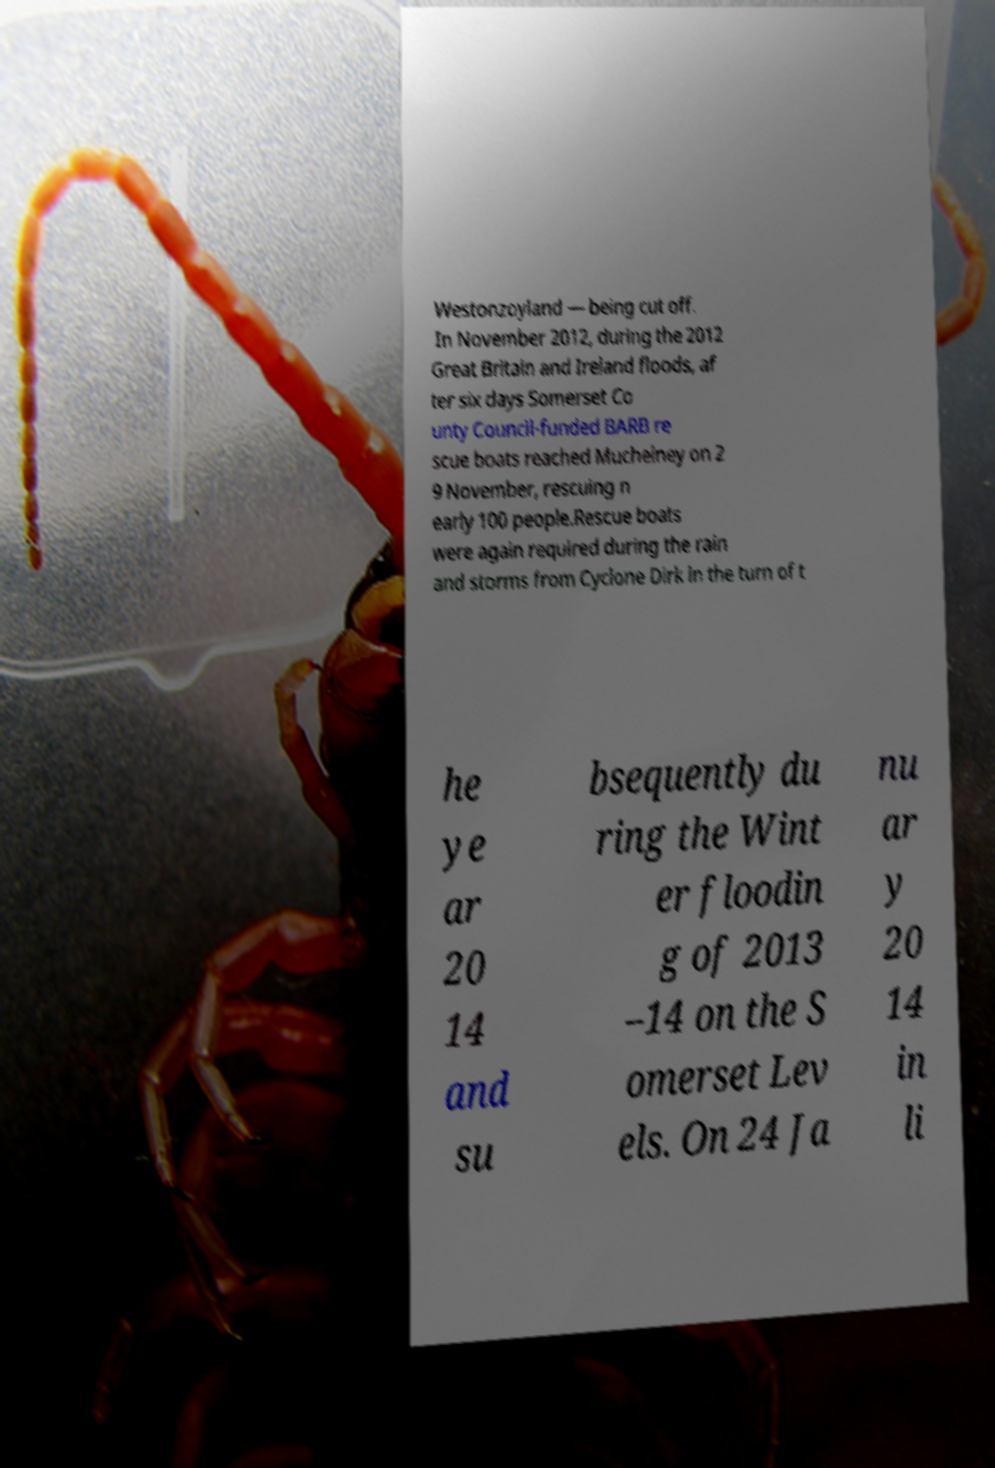There's text embedded in this image that I need extracted. Can you transcribe it verbatim? Westonzoyland — being cut off. In November 2012, during the 2012 Great Britain and Ireland floods, af ter six days Somerset Co unty Council-funded BARB re scue boats reached Muchelney on 2 9 November, rescuing n early 100 people.Rescue boats were again required during the rain and storms from Cyclone Dirk in the turn of t he ye ar 20 14 and su bsequently du ring the Wint er floodin g of 2013 –14 on the S omerset Lev els. On 24 Ja nu ar y 20 14 in li 